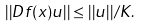<formula> <loc_0><loc_0><loc_500><loc_500>| | D f ( x ) u | | \leq | | u | | / K .</formula> 